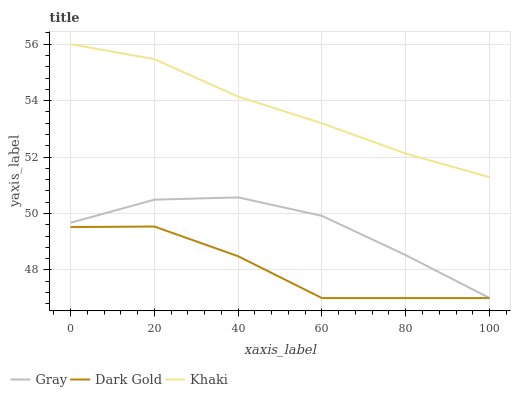Does Dark Gold have the minimum area under the curve?
Answer yes or no. Yes. Does Khaki have the maximum area under the curve?
Answer yes or no. Yes. Does Khaki have the minimum area under the curve?
Answer yes or no. No. Does Dark Gold have the maximum area under the curve?
Answer yes or no. No. Is Khaki the smoothest?
Answer yes or no. Yes. Is Dark Gold the roughest?
Answer yes or no. Yes. Is Dark Gold the smoothest?
Answer yes or no. No. Is Khaki the roughest?
Answer yes or no. No. Does Gray have the lowest value?
Answer yes or no. Yes. Does Khaki have the lowest value?
Answer yes or no. No. Does Khaki have the highest value?
Answer yes or no. Yes. Does Dark Gold have the highest value?
Answer yes or no. No. Is Gray less than Khaki?
Answer yes or no. Yes. Is Khaki greater than Gray?
Answer yes or no. Yes. Does Gray intersect Dark Gold?
Answer yes or no. Yes. Is Gray less than Dark Gold?
Answer yes or no. No. Is Gray greater than Dark Gold?
Answer yes or no. No. Does Gray intersect Khaki?
Answer yes or no. No. 